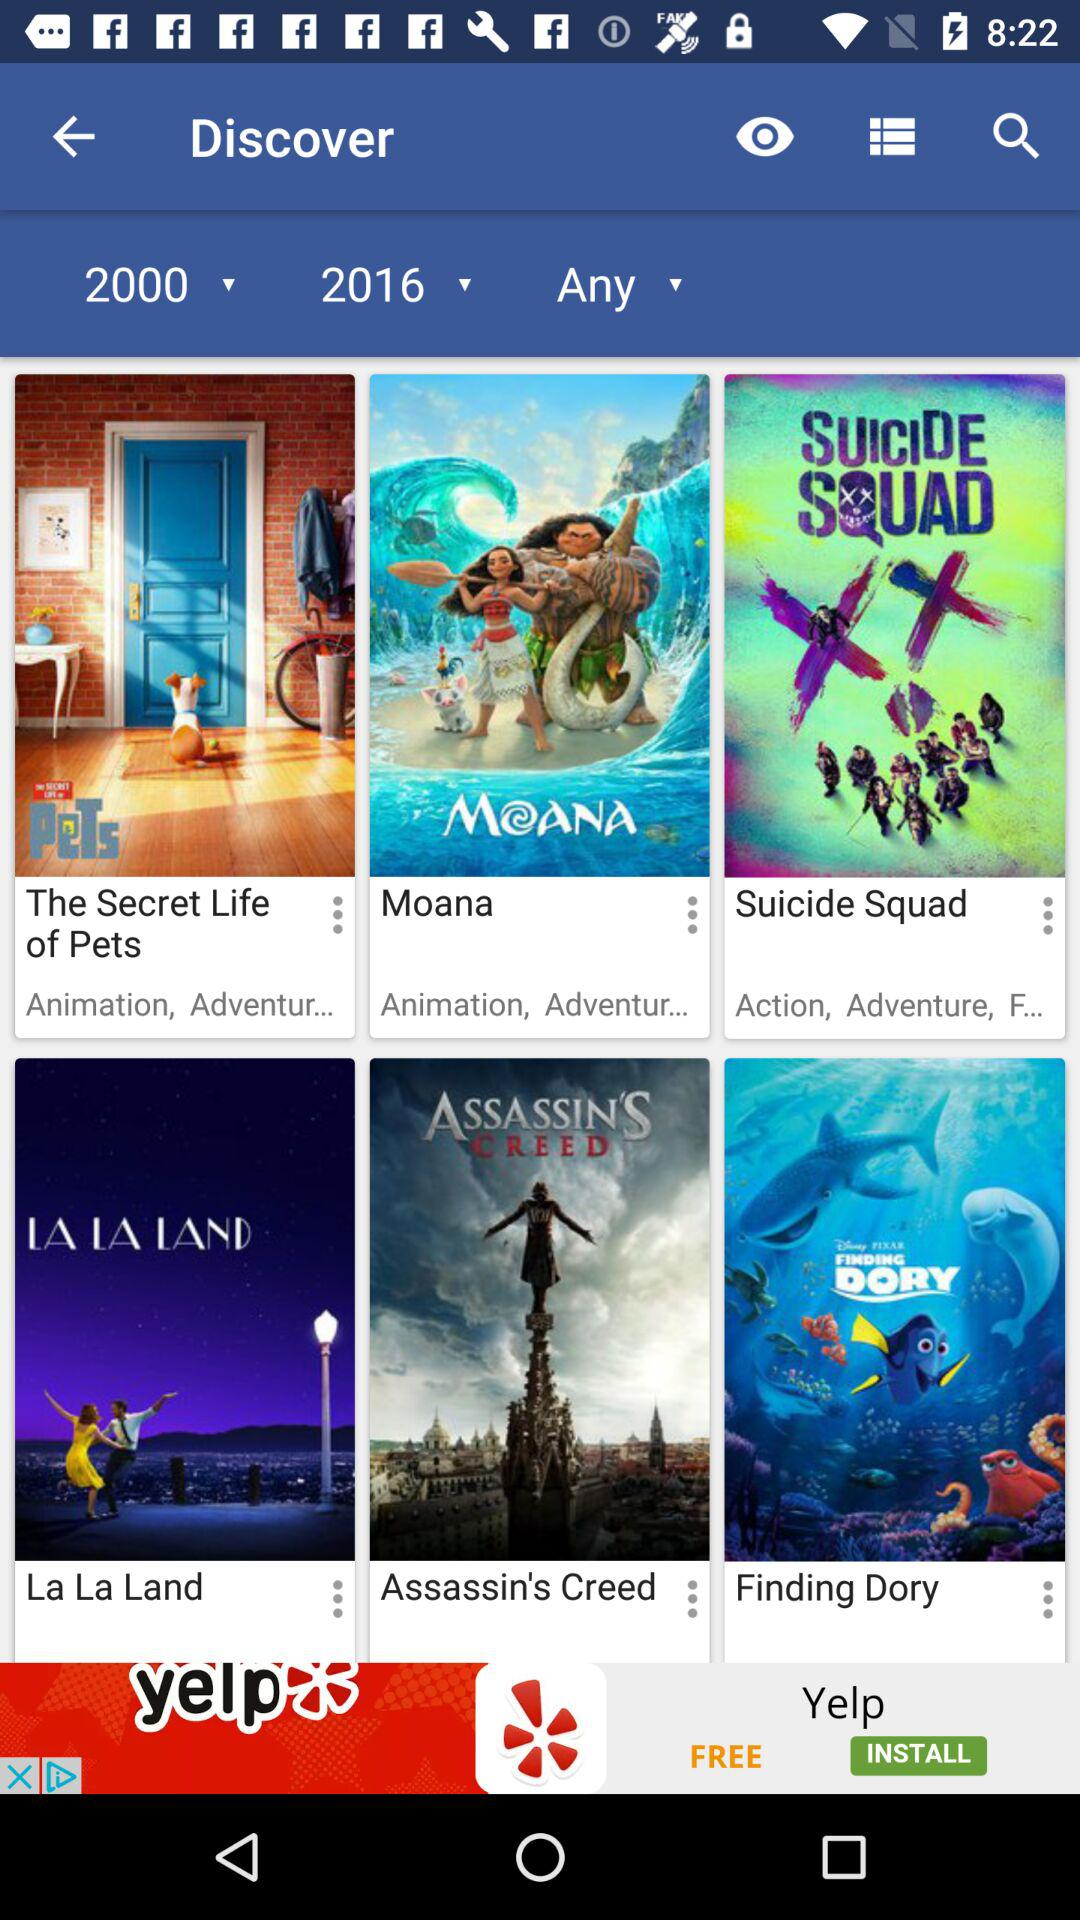What are the mentioned years? The mentioned years are 2000 and 2016. 